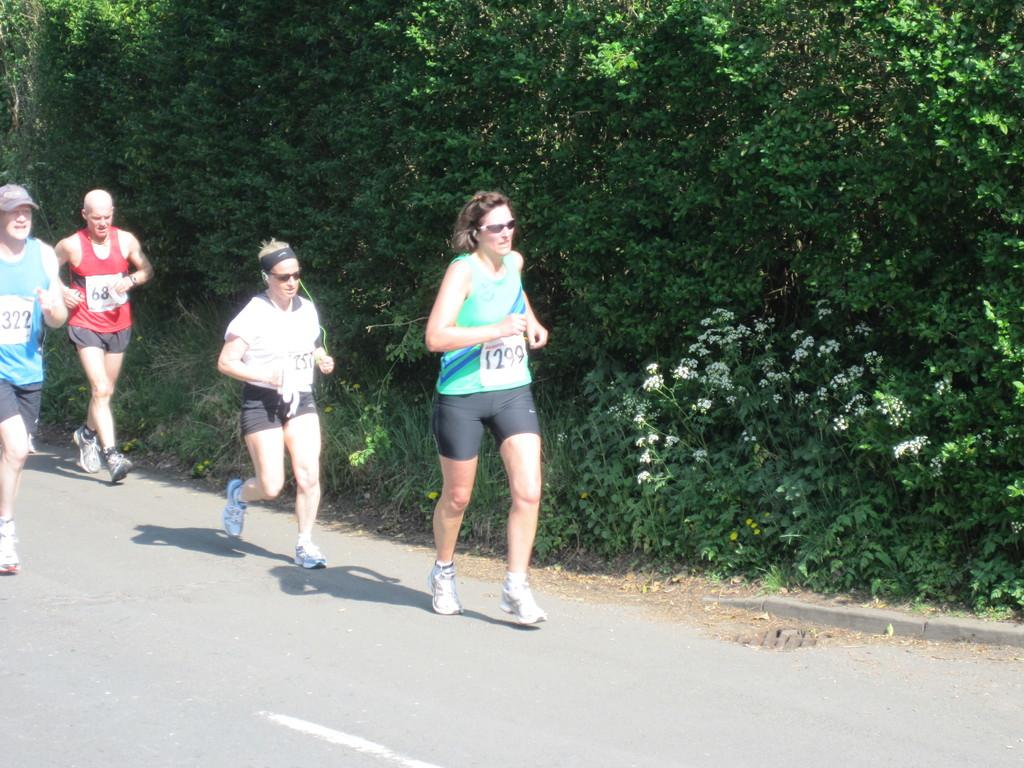Who is present in the image? There are people in the image. Where are the people located? The people are on a road. What type of vegetation can be seen in the image? There are plants and trees in the image. What type of brick is being used to build the father's house in the image? There is no father or house present in the image, and therefore no bricks can be observed. 